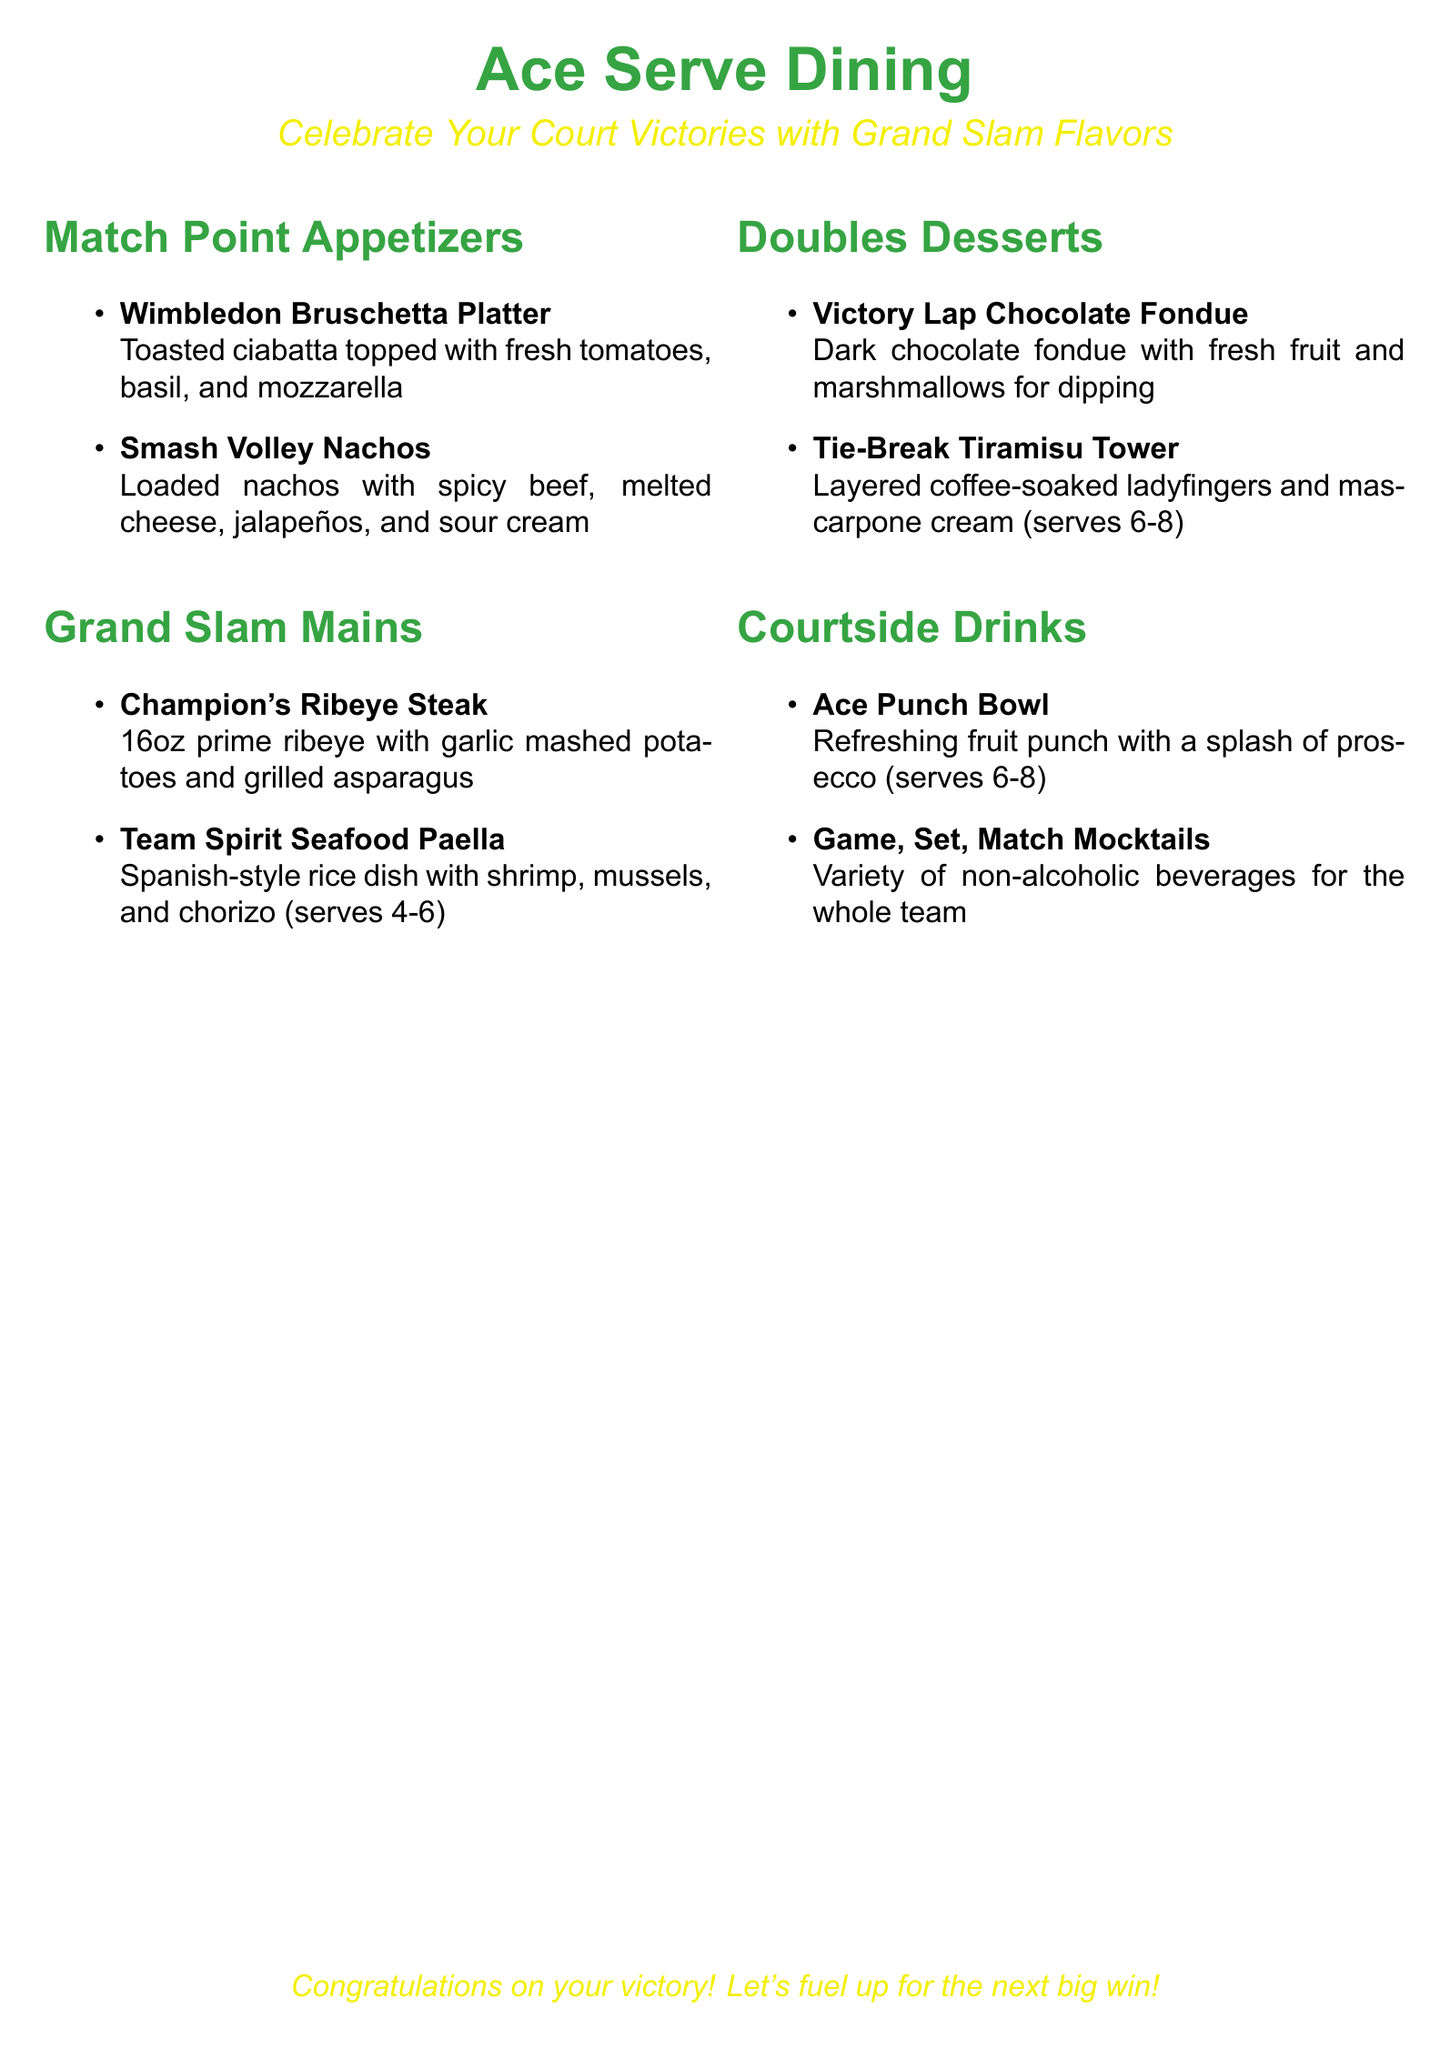What is the name of the appetizer platter? The name of the appetizer platter is listed as "Wimbledon Bruschetta Platter" in the menu.
Answer: Wimbledon Bruschetta Platter How many ounces is the Champion's Ribeye Steak? The menu specifies that the Champion's Ribeye Steak is 16oz.
Answer: 16oz What type of seafood is in the Team Spirit Seafood Paella? The seafood included in the Team Spirit Seafood Paella is shrimp, mussels, and chorizo, which are mentioned in the description.
Answer: shrimp, mussels, and chorizo How many servings does the Tie-Break Tiramisu Tower provide? The menu indicates that the Tie-Break Tiramisu Tower serves 6-8.
Answer: 6-8 What drink is served in a punch bowl? The drink served in a punch bowl is called "Ace Punch Bowl" according to the menu.
Answer: Ace Punch Bowl Which dessert features dark chocolate fondue? The dessert featuring dark chocolate fondue is called "Victory Lap Chocolate Fondue" in the menu.
Answer: Victory Lap Chocolate Fondue How is the Ace Punch Bowl described in terms of servings? The menu describes the Ace Punch Bowl as serving 6-8 people.
Answer: 6-8 What is the theme of the dining experience? The theme of the dining experience is celebrating court victories with grand slam flavors, as stated in the introduction.
Answer: grand slam flavors What type of beverages are available for those who do not drink alcohol? The menu offers "Game, Set, Match Mocktails" as non-alcoholic beverage options for the whole team.
Answer: Game, Set, Match Mocktails 